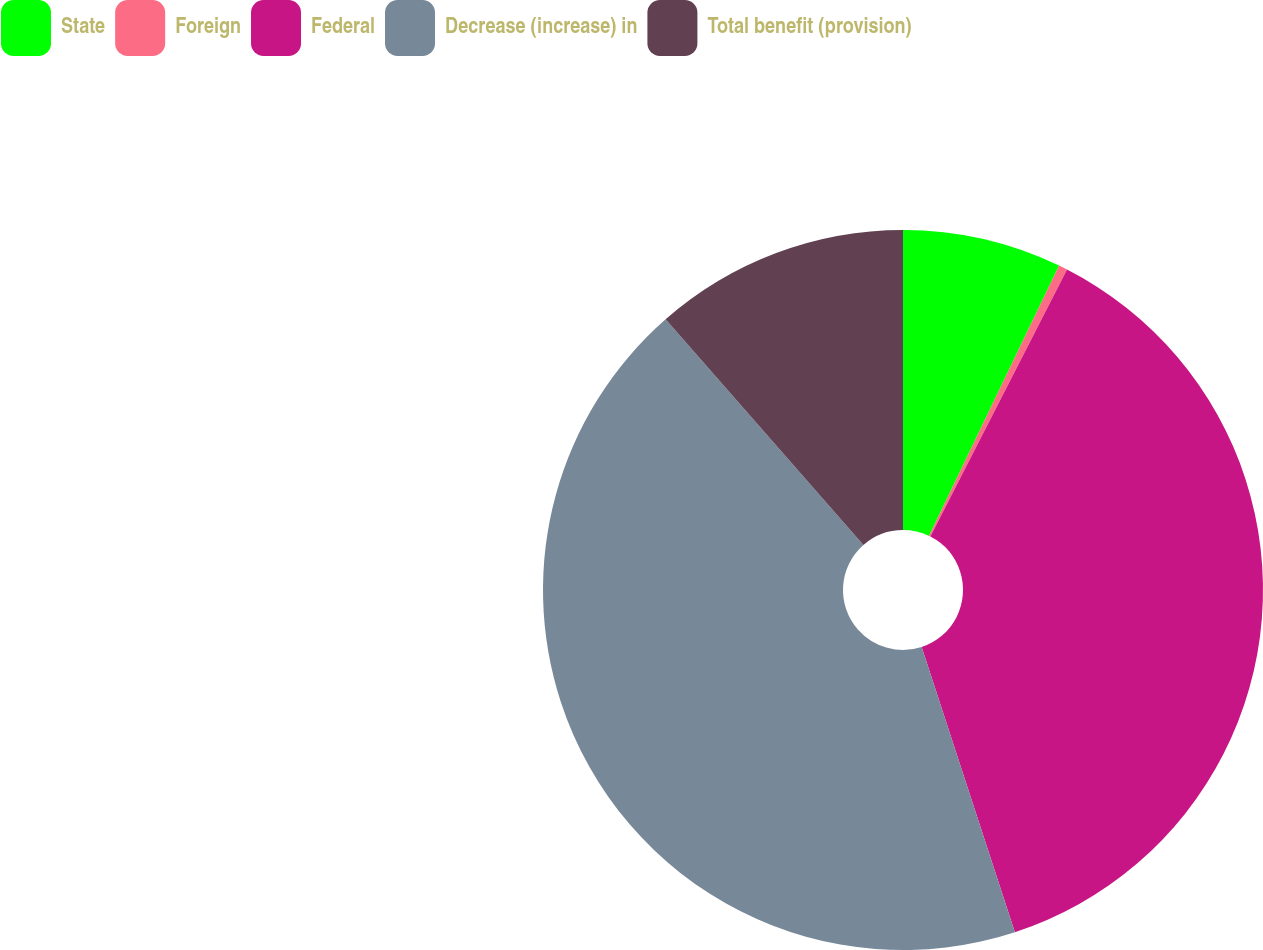<chart> <loc_0><loc_0><loc_500><loc_500><pie_chart><fcel>State<fcel>Foreign<fcel>Federal<fcel>Decrease (increase) in<fcel>Total benefit (provision)<nl><fcel>7.14%<fcel>0.39%<fcel>37.44%<fcel>43.57%<fcel>11.46%<nl></chart> 